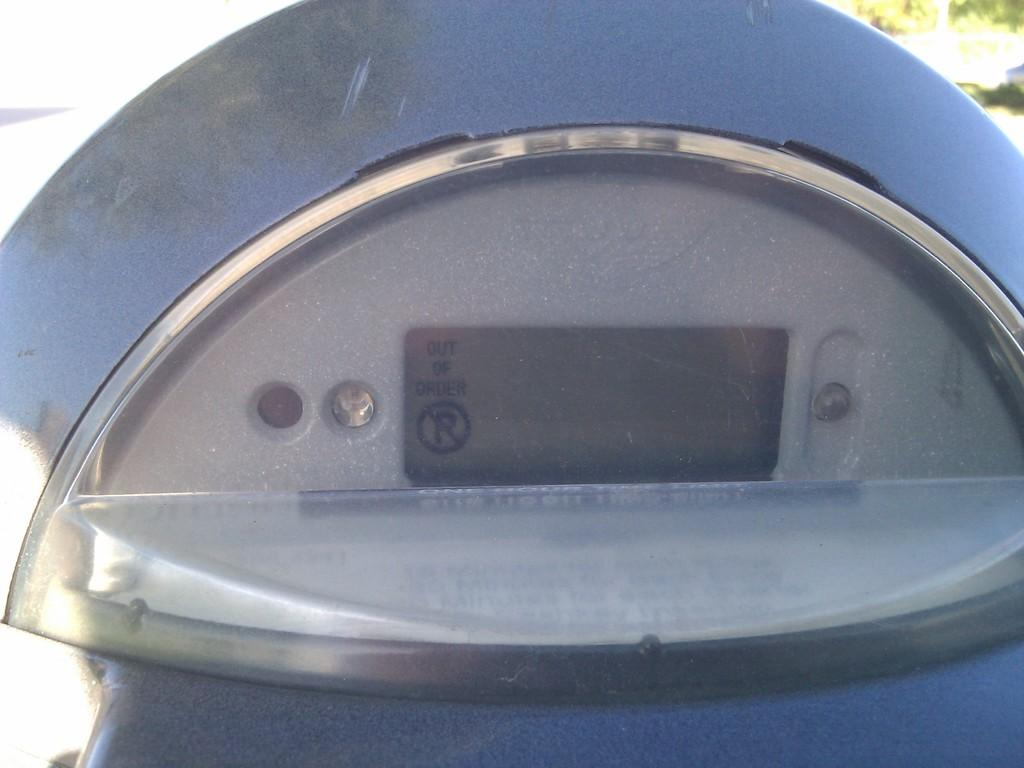What is the main subject of the image? The main subject of the image is a parking ticket meter display. What type of fowl can be seen interacting with the parking ticket meter display in the image? There is no fowl present in the image, and therefore no such interaction can be observed. 